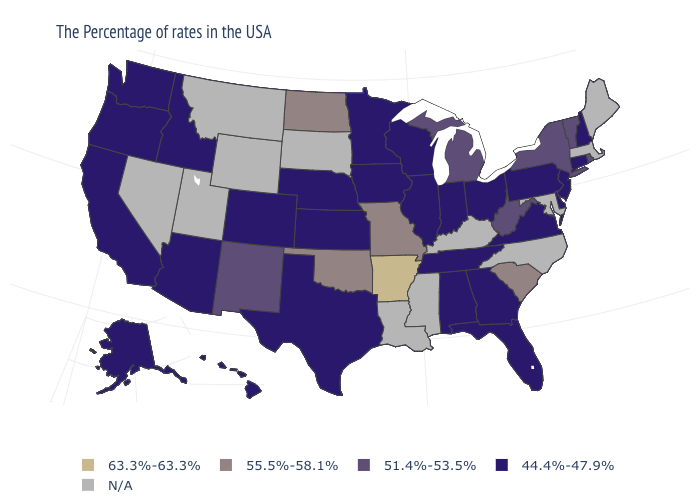Name the states that have a value in the range 51.4%-53.5%?
Quick response, please. Rhode Island, Vermont, New York, West Virginia, Michigan, New Mexico. What is the value of Wyoming?
Short answer required. N/A. What is the lowest value in the USA?
Short answer required. 44.4%-47.9%. Does the first symbol in the legend represent the smallest category?
Short answer required. No. Name the states that have a value in the range 63.3%-63.3%?
Answer briefly. Arkansas. What is the value of Delaware?
Concise answer only. 44.4%-47.9%. What is the lowest value in the USA?
Write a very short answer. 44.4%-47.9%. Does Arkansas have the highest value in the USA?
Be succinct. Yes. Does the first symbol in the legend represent the smallest category?
Quick response, please. No. Which states have the highest value in the USA?
Concise answer only. Arkansas. Among the states that border Kentucky , which have the lowest value?
Concise answer only. Virginia, Ohio, Indiana, Tennessee, Illinois. Name the states that have a value in the range 44.4%-47.9%?
Answer briefly. New Hampshire, Connecticut, New Jersey, Delaware, Pennsylvania, Virginia, Ohio, Florida, Georgia, Indiana, Alabama, Tennessee, Wisconsin, Illinois, Minnesota, Iowa, Kansas, Nebraska, Texas, Colorado, Arizona, Idaho, California, Washington, Oregon, Alaska, Hawaii. 